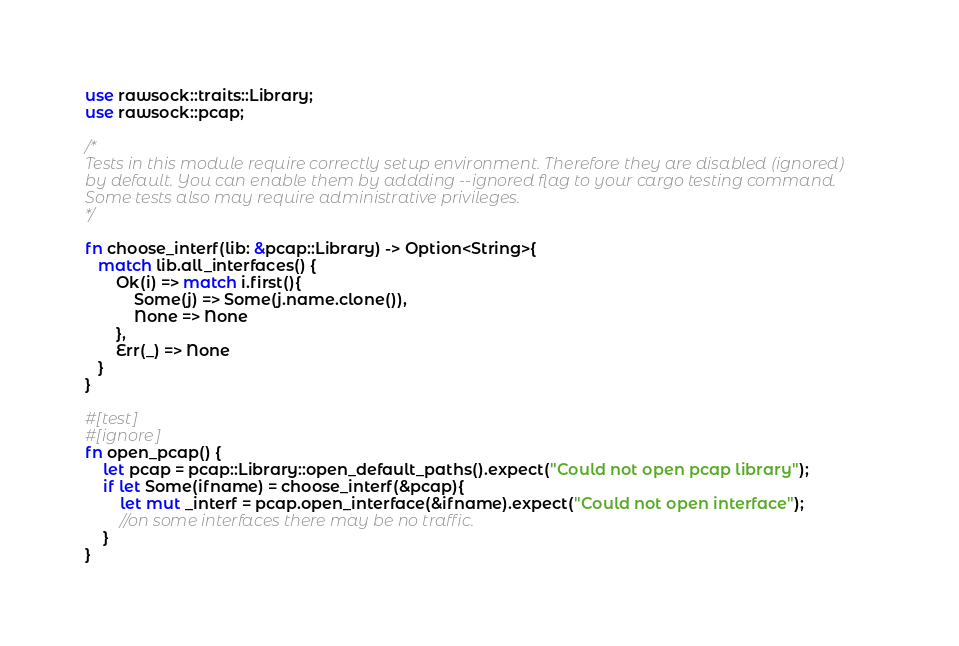Convert code to text. <code><loc_0><loc_0><loc_500><loc_500><_Rust_>use rawsock::traits::Library;
use rawsock::pcap;

/*
Tests in this module require correctly setup environment. Therefore they are disabled (ignored)
by default. You can enable them by addding --ignored flag to your cargo testing command.
Some tests also may require administrative privileges.
*/

fn choose_interf(lib: &pcap::Library) -> Option<String>{
   match lib.all_interfaces() {
       Ok(i) => match i.first(){
           Some(j) => Some(j.name.clone()),
           None => None
       },
       Err(_) => None
   }
}

#[test]
#[ignore]
fn open_pcap() {
    let pcap = pcap::Library::open_default_paths().expect("Could not open pcap library");
    if let Some(ifname) = choose_interf(&pcap){
        let mut _interf = pcap.open_interface(&ifname).expect("Could not open interface");
        //on some interfaces there may be no traffic.
    }
}</code> 